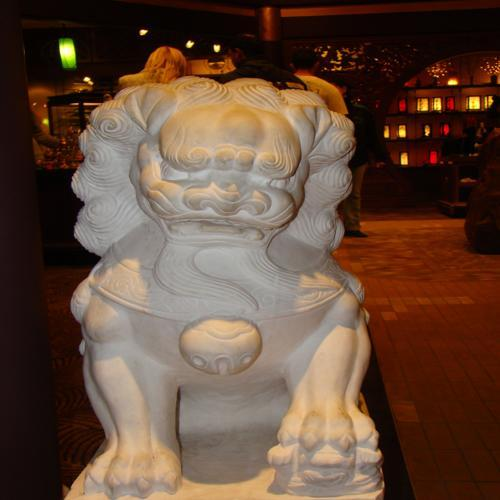What is the purpose of the ball under the lion's paw? The ball, also known as the 'Flower of Life,' 'Heavenly Creations,' or 'embroidered ball,' often found under the paw of Chinese guardian lion statues, symbolizes unity and completeness. It is also thought to represent the seed of life, symbolizing endless possibilities and is sometimes interpreted as a metaphor for the lion's dominance over the world. 